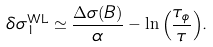<formula> <loc_0><loc_0><loc_500><loc_500>\delta \sigma ^ { \text {WL} } _ { 1 } \simeq \frac { \Delta { \sigma ( B ) } } { \alpha } - \ln { \left ( \frac { \tau _ { \phi } } { \tau } \right ) } .</formula> 